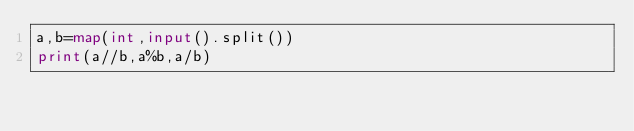Convert code to text. <code><loc_0><loc_0><loc_500><loc_500><_Python_>a,b=map(int,input().split())
print(a//b,a%b,a/b)</code> 